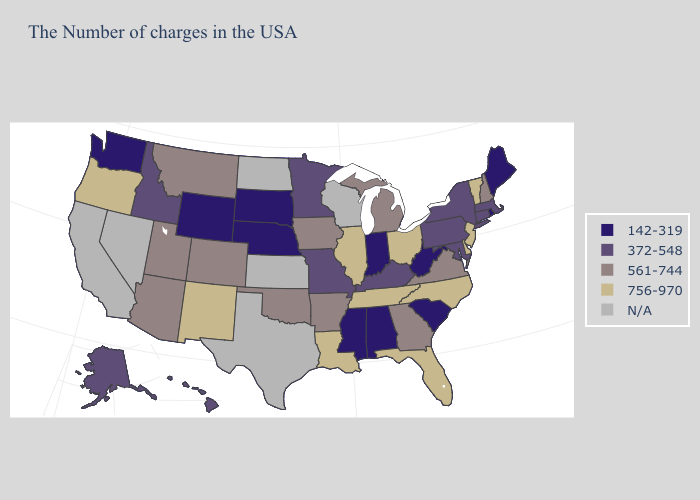Name the states that have a value in the range 142-319?
Write a very short answer. Maine, Rhode Island, South Carolina, West Virginia, Indiana, Alabama, Mississippi, Nebraska, South Dakota, Wyoming, Washington. Name the states that have a value in the range N/A?
Concise answer only. Wisconsin, Kansas, Texas, North Dakota, Nevada, California. Which states have the highest value in the USA?
Be succinct. Vermont, New Jersey, Delaware, North Carolina, Ohio, Florida, Tennessee, Illinois, Louisiana, New Mexico, Oregon. What is the highest value in states that border Arizona?
Quick response, please. 756-970. Does the map have missing data?
Quick response, please. Yes. What is the lowest value in the USA?
Keep it brief. 142-319. Among the states that border Vermont , does New Hampshire have the lowest value?
Keep it brief. No. Name the states that have a value in the range 756-970?
Short answer required. Vermont, New Jersey, Delaware, North Carolina, Ohio, Florida, Tennessee, Illinois, Louisiana, New Mexico, Oregon. What is the value of Tennessee?
Give a very brief answer. 756-970. How many symbols are there in the legend?
Short answer required. 5. Does Hawaii have the highest value in the West?
Give a very brief answer. No. What is the value of Delaware?
Be succinct. 756-970. What is the value of Maine?
Keep it brief. 142-319. Name the states that have a value in the range 142-319?
Write a very short answer. Maine, Rhode Island, South Carolina, West Virginia, Indiana, Alabama, Mississippi, Nebraska, South Dakota, Wyoming, Washington. 